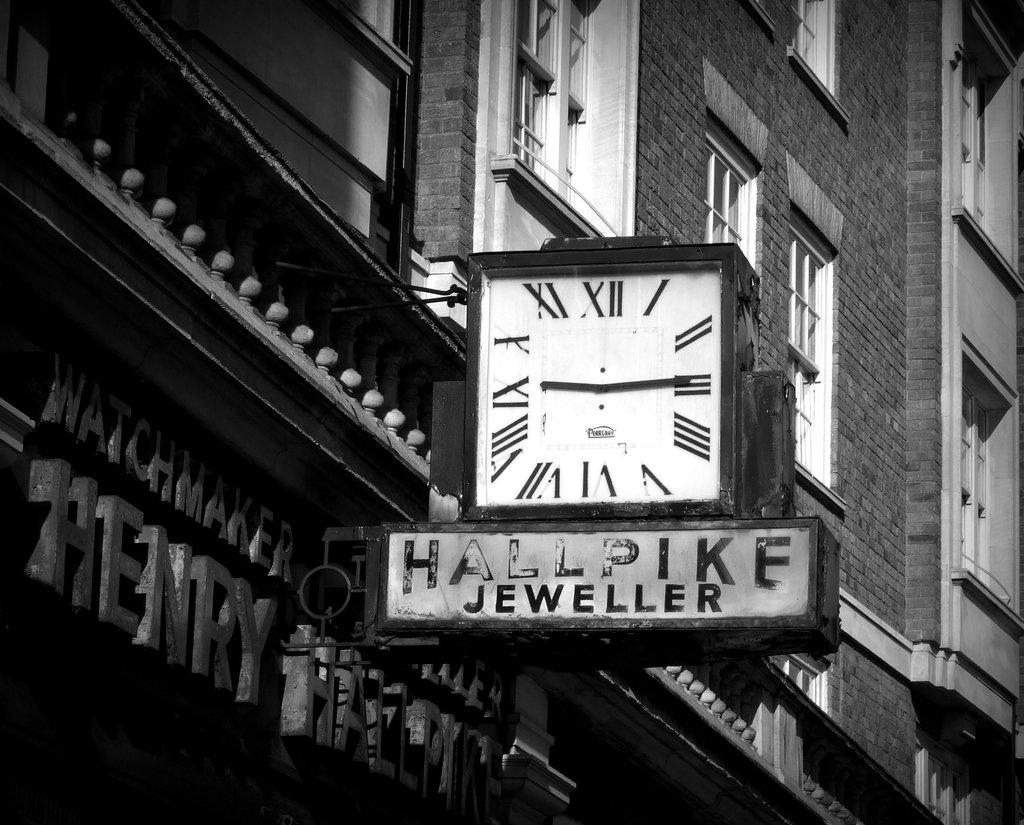Provide a one-sentence caption for the provided image. a clock with the advertisement Hallpike Jeweller is on a building. 